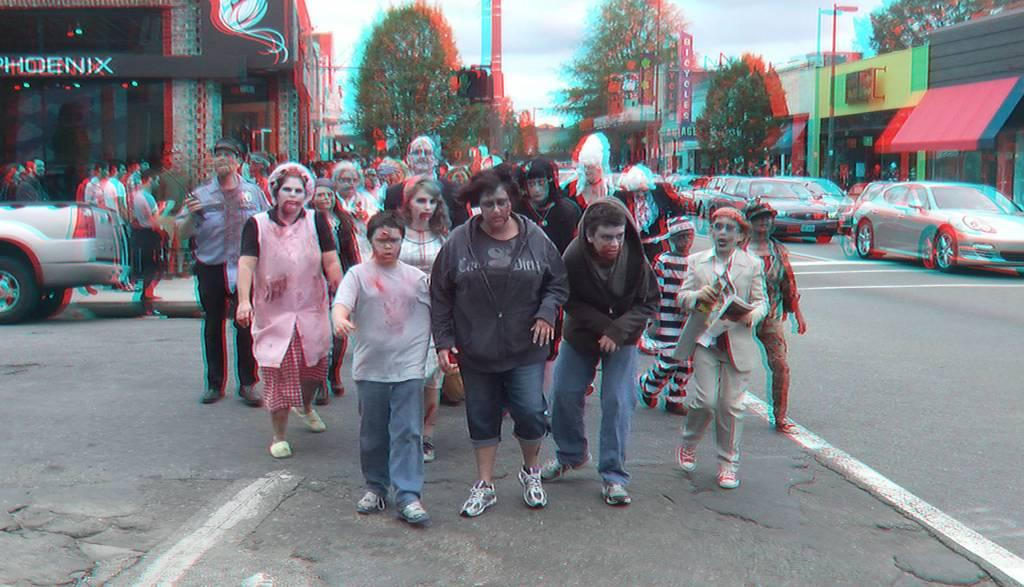What are the people in the image doing? There is a group of people walking on the road in the image. What else can be seen on the road? There are vehicles parked on the road. What type of vegetation is visible in the image? Trees are visible in the image. What structures are present to regulate traffic? Traffic signal poles are present in the image. What can be seen in the background of the image? There are buildings and the sky visible in the background. Where is the sponge placed on the tray in the image? There is no sponge or tray present in the image. What is the thumb doing in the image? There is no thumb visible in the image. 